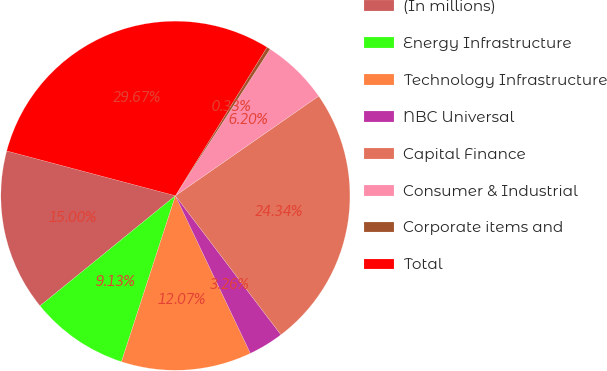Convert chart. <chart><loc_0><loc_0><loc_500><loc_500><pie_chart><fcel>(In millions)<fcel>Energy Infrastructure<fcel>Technology Infrastructure<fcel>NBC Universal<fcel>Capital Finance<fcel>Consumer & Industrial<fcel>Corporate items and<fcel>Total<nl><fcel>15.0%<fcel>9.13%<fcel>12.07%<fcel>3.26%<fcel>24.34%<fcel>6.2%<fcel>0.33%<fcel>29.67%<nl></chart> 